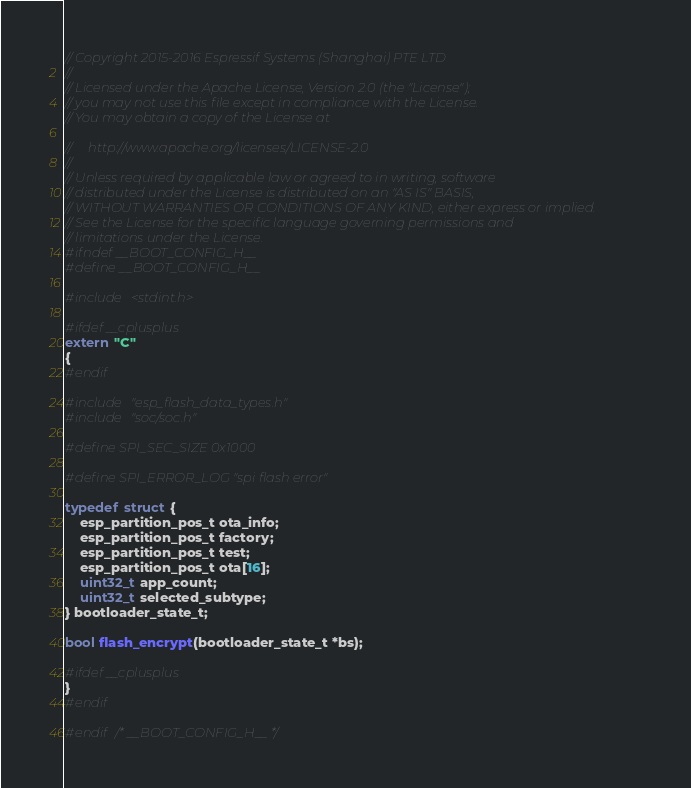Convert code to text. <code><loc_0><loc_0><loc_500><loc_500><_C_>// Copyright 2015-2016 Espressif Systems (Shanghai) PTE LTD
//
// Licensed under the Apache License, Version 2.0 (the "License");
// you may not use this file except in compliance with the License.
// You may obtain a copy of the License at

//     http://www.apache.org/licenses/LICENSE-2.0
//
// Unless required by applicable law or agreed to in writing, software
// distributed under the License is distributed on an "AS IS" BASIS,
// WITHOUT WARRANTIES OR CONDITIONS OF ANY KIND, either express or implied.
// See the License for the specific language governing permissions and
// limitations under the License.
#ifndef __BOOT_CONFIG_H__
#define __BOOT_CONFIG_H__

#include <stdint.h>

#ifdef __cplusplus
extern "C"
{
#endif

#include "esp_flash_data_types.h"
#include "soc/soc.h"

#define SPI_SEC_SIZE 0x1000

#define SPI_ERROR_LOG "spi flash error"

typedef struct {
    esp_partition_pos_t ota_info;
    esp_partition_pos_t factory;
    esp_partition_pos_t test;
    esp_partition_pos_t ota[16];
    uint32_t app_count;
    uint32_t selected_subtype;
} bootloader_state_t;

bool flash_encrypt(bootloader_state_t *bs);

#ifdef __cplusplus
}
#endif

#endif /* __BOOT_CONFIG_H__ */
</code> 